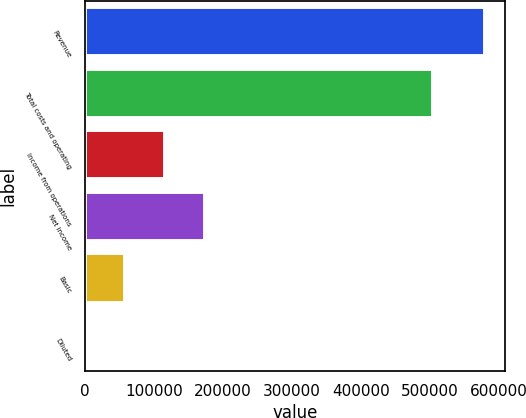Convert chart. <chart><loc_0><loc_0><loc_500><loc_500><bar_chart><fcel>Revenue<fcel>Total costs and operating<fcel>Income from operations<fcel>Net income<fcel>Basic<fcel>Diluted<nl><fcel>579036<fcel>504156<fcel>115808<fcel>173711<fcel>57904.2<fcel>0.65<nl></chart> 